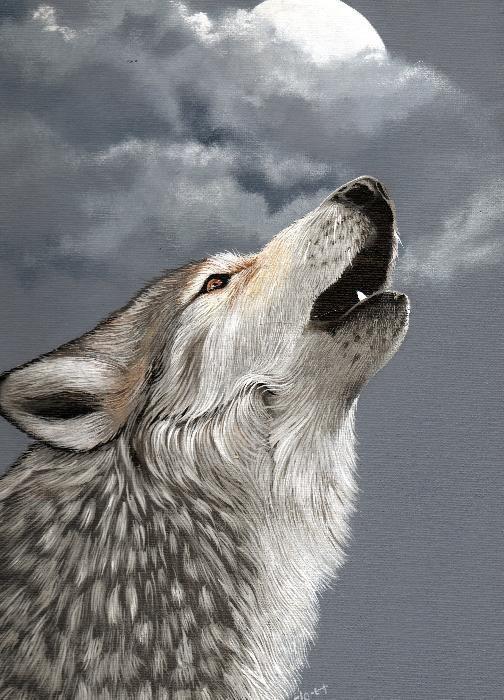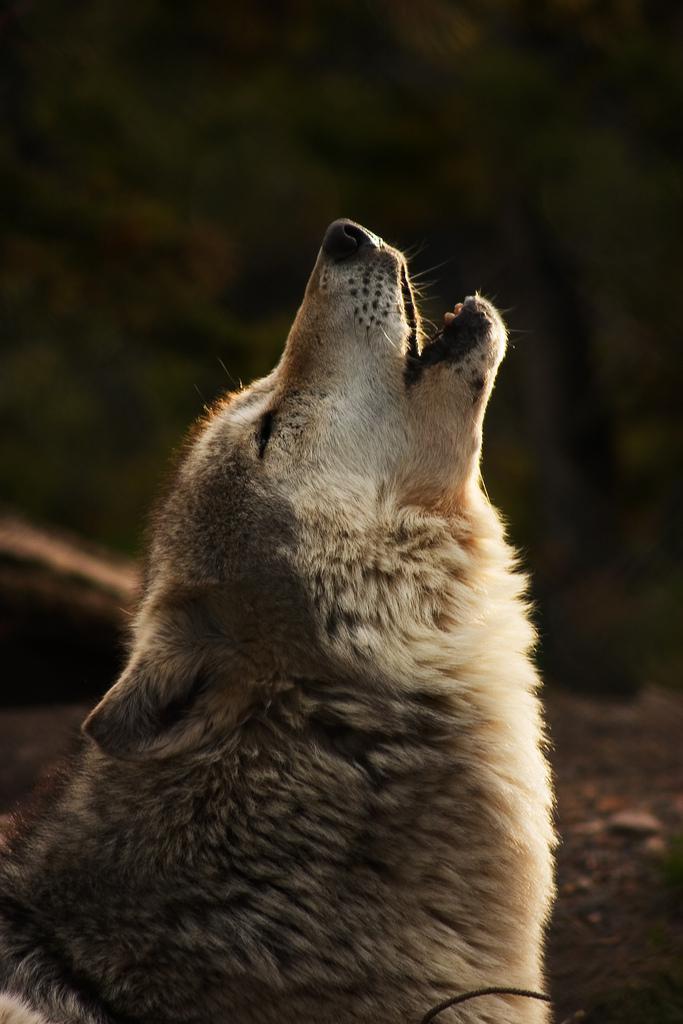The first image is the image on the left, the second image is the image on the right. Given the left and right images, does the statement "Each image shows exactly one howling wolf." hold true? Answer yes or no. Yes. 